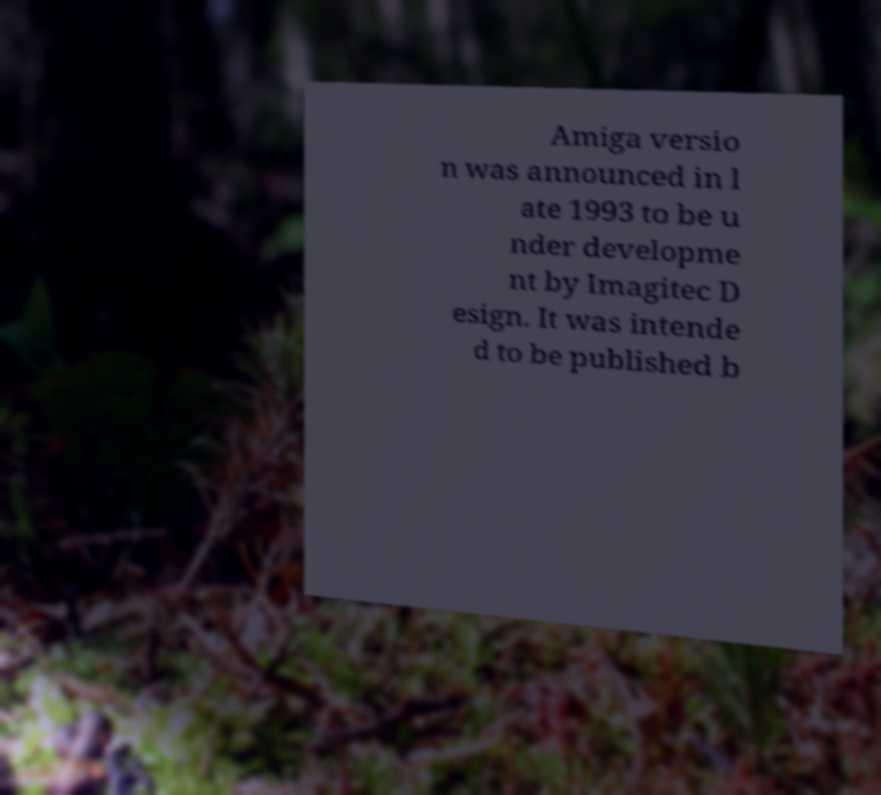What messages or text are displayed in this image? I need them in a readable, typed format. Amiga versio n was announced in l ate 1993 to be u nder developme nt by Imagitec D esign. It was intende d to be published b 